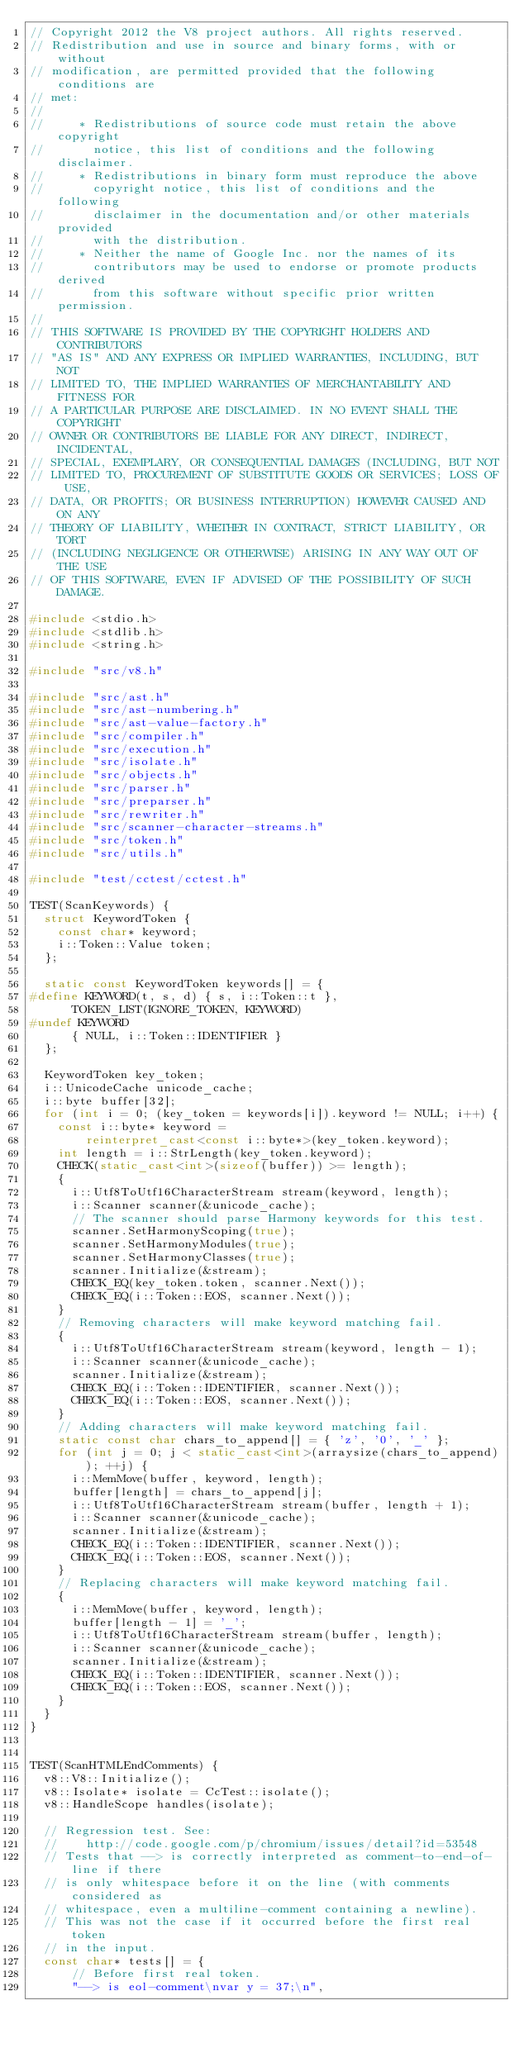Convert code to text. <code><loc_0><loc_0><loc_500><loc_500><_C++_>// Copyright 2012 the V8 project authors. All rights reserved.
// Redistribution and use in source and binary forms, with or without
// modification, are permitted provided that the following conditions are
// met:
//
//     * Redistributions of source code must retain the above copyright
//       notice, this list of conditions and the following disclaimer.
//     * Redistributions in binary form must reproduce the above
//       copyright notice, this list of conditions and the following
//       disclaimer in the documentation and/or other materials provided
//       with the distribution.
//     * Neither the name of Google Inc. nor the names of its
//       contributors may be used to endorse or promote products derived
//       from this software without specific prior written permission.
//
// THIS SOFTWARE IS PROVIDED BY THE COPYRIGHT HOLDERS AND CONTRIBUTORS
// "AS IS" AND ANY EXPRESS OR IMPLIED WARRANTIES, INCLUDING, BUT NOT
// LIMITED TO, THE IMPLIED WARRANTIES OF MERCHANTABILITY AND FITNESS FOR
// A PARTICULAR PURPOSE ARE DISCLAIMED. IN NO EVENT SHALL THE COPYRIGHT
// OWNER OR CONTRIBUTORS BE LIABLE FOR ANY DIRECT, INDIRECT, INCIDENTAL,
// SPECIAL, EXEMPLARY, OR CONSEQUENTIAL DAMAGES (INCLUDING, BUT NOT
// LIMITED TO, PROCUREMENT OF SUBSTITUTE GOODS OR SERVICES; LOSS OF USE,
// DATA, OR PROFITS; OR BUSINESS INTERRUPTION) HOWEVER CAUSED AND ON ANY
// THEORY OF LIABILITY, WHETHER IN CONTRACT, STRICT LIABILITY, OR TORT
// (INCLUDING NEGLIGENCE OR OTHERWISE) ARISING IN ANY WAY OUT OF THE USE
// OF THIS SOFTWARE, EVEN IF ADVISED OF THE POSSIBILITY OF SUCH DAMAGE.

#include <stdio.h>
#include <stdlib.h>
#include <string.h>

#include "src/v8.h"

#include "src/ast.h"
#include "src/ast-numbering.h"
#include "src/ast-value-factory.h"
#include "src/compiler.h"
#include "src/execution.h"
#include "src/isolate.h"
#include "src/objects.h"
#include "src/parser.h"
#include "src/preparser.h"
#include "src/rewriter.h"
#include "src/scanner-character-streams.h"
#include "src/token.h"
#include "src/utils.h"

#include "test/cctest/cctest.h"

TEST(ScanKeywords) {
  struct KeywordToken {
    const char* keyword;
    i::Token::Value token;
  };

  static const KeywordToken keywords[] = {
#define KEYWORD(t, s, d) { s, i::Token::t },
      TOKEN_LIST(IGNORE_TOKEN, KEYWORD)
#undef KEYWORD
      { NULL, i::Token::IDENTIFIER }
  };

  KeywordToken key_token;
  i::UnicodeCache unicode_cache;
  i::byte buffer[32];
  for (int i = 0; (key_token = keywords[i]).keyword != NULL; i++) {
    const i::byte* keyword =
        reinterpret_cast<const i::byte*>(key_token.keyword);
    int length = i::StrLength(key_token.keyword);
    CHECK(static_cast<int>(sizeof(buffer)) >= length);
    {
      i::Utf8ToUtf16CharacterStream stream(keyword, length);
      i::Scanner scanner(&unicode_cache);
      // The scanner should parse Harmony keywords for this test.
      scanner.SetHarmonyScoping(true);
      scanner.SetHarmonyModules(true);
      scanner.SetHarmonyClasses(true);
      scanner.Initialize(&stream);
      CHECK_EQ(key_token.token, scanner.Next());
      CHECK_EQ(i::Token::EOS, scanner.Next());
    }
    // Removing characters will make keyword matching fail.
    {
      i::Utf8ToUtf16CharacterStream stream(keyword, length - 1);
      i::Scanner scanner(&unicode_cache);
      scanner.Initialize(&stream);
      CHECK_EQ(i::Token::IDENTIFIER, scanner.Next());
      CHECK_EQ(i::Token::EOS, scanner.Next());
    }
    // Adding characters will make keyword matching fail.
    static const char chars_to_append[] = { 'z', '0', '_' };
    for (int j = 0; j < static_cast<int>(arraysize(chars_to_append)); ++j) {
      i::MemMove(buffer, keyword, length);
      buffer[length] = chars_to_append[j];
      i::Utf8ToUtf16CharacterStream stream(buffer, length + 1);
      i::Scanner scanner(&unicode_cache);
      scanner.Initialize(&stream);
      CHECK_EQ(i::Token::IDENTIFIER, scanner.Next());
      CHECK_EQ(i::Token::EOS, scanner.Next());
    }
    // Replacing characters will make keyword matching fail.
    {
      i::MemMove(buffer, keyword, length);
      buffer[length - 1] = '_';
      i::Utf8ToUtf16CharacterStream stream(buffer, length);
      i::Scanner scanner(&unicode_cache);
      scanner.Initialize(&stream);
      CHECK_EQ(i::Token::IDENTIFIER, scanner.Next());
      CHECK_EQ(i::Token::EOS, scanner.Next());
    }
  }
}


TEST(ScanHTMLEndComments) {
  v8::V8::Initialize();
  v8::Isolate* isolate = CcTest::isolate();
  v8::HandleScope handles(isolate);

  // Regression test. See:
  //    http://code.google.com/p/chromium/issues/detail?id=53548
  // Tests that --> is correctly interpreted as comment-to-end-of-line if there
  // is only whitespace before it on the line (with comments considered as
  // whitespace, even a multiline-comment containing a newline).
  // This was not the case if it occurred before the first real token
  // in the input.
  const char* tests[] = {
      // Before first real token.
      "--> is eol-comment\nvar y = 37;\n",</code> 